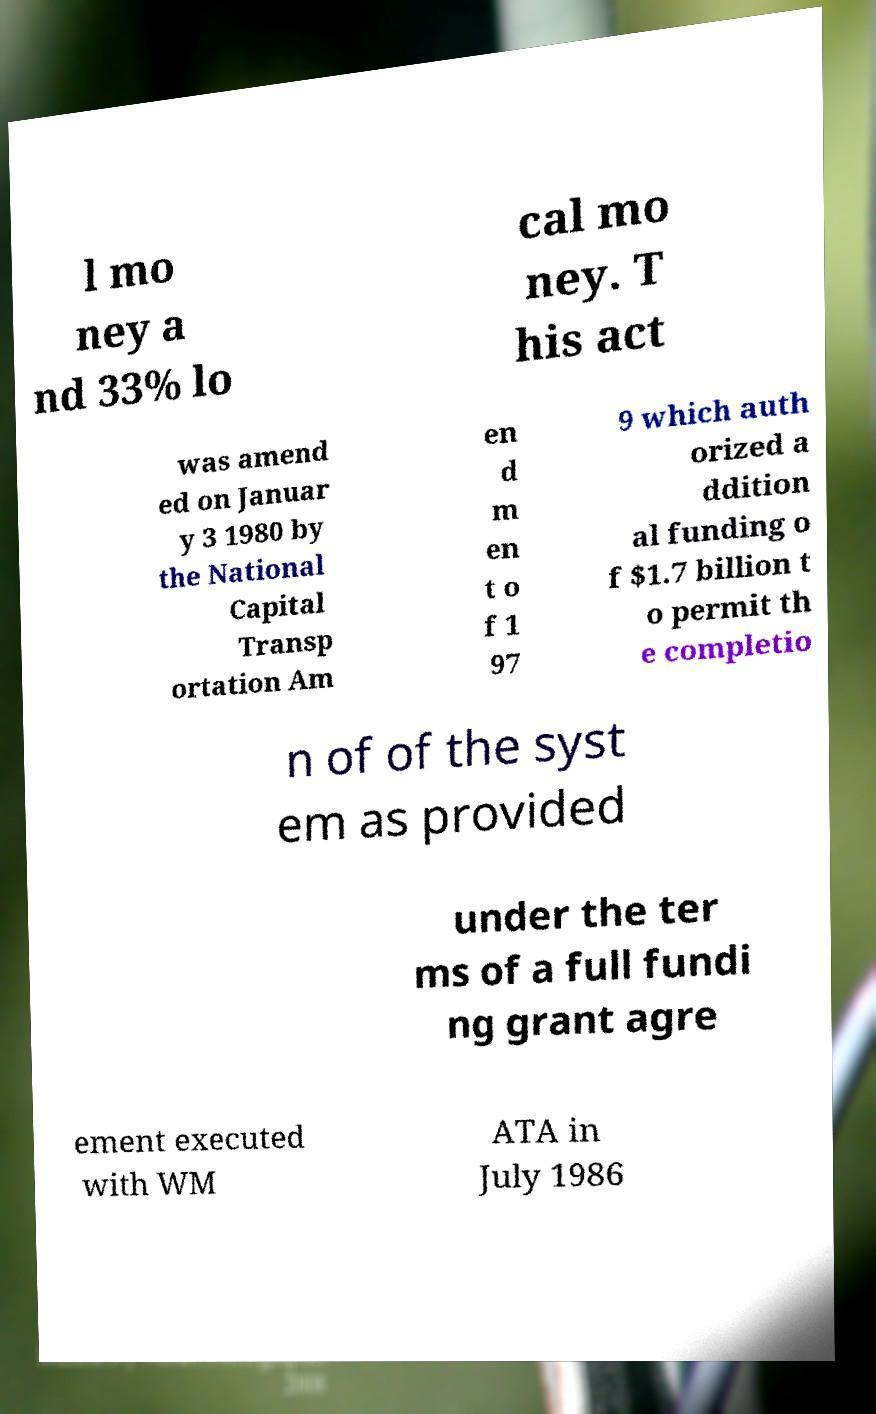For documentation purposes, I need the text within this image transcribed. Could you provide that? l mo ney a nd 33% lo cal mo ney. T his act was amend ed on Januar y 3 1980 by the National Capital Transp ortation Am en d m en t o f 1 97 9 which auth orized a ddition al funding o f $1.7 billion t o permit th e completio n of of the syst em as provided under the ter ms of a full fundi ng grant agre ement executed with WM ATA in July 1986 